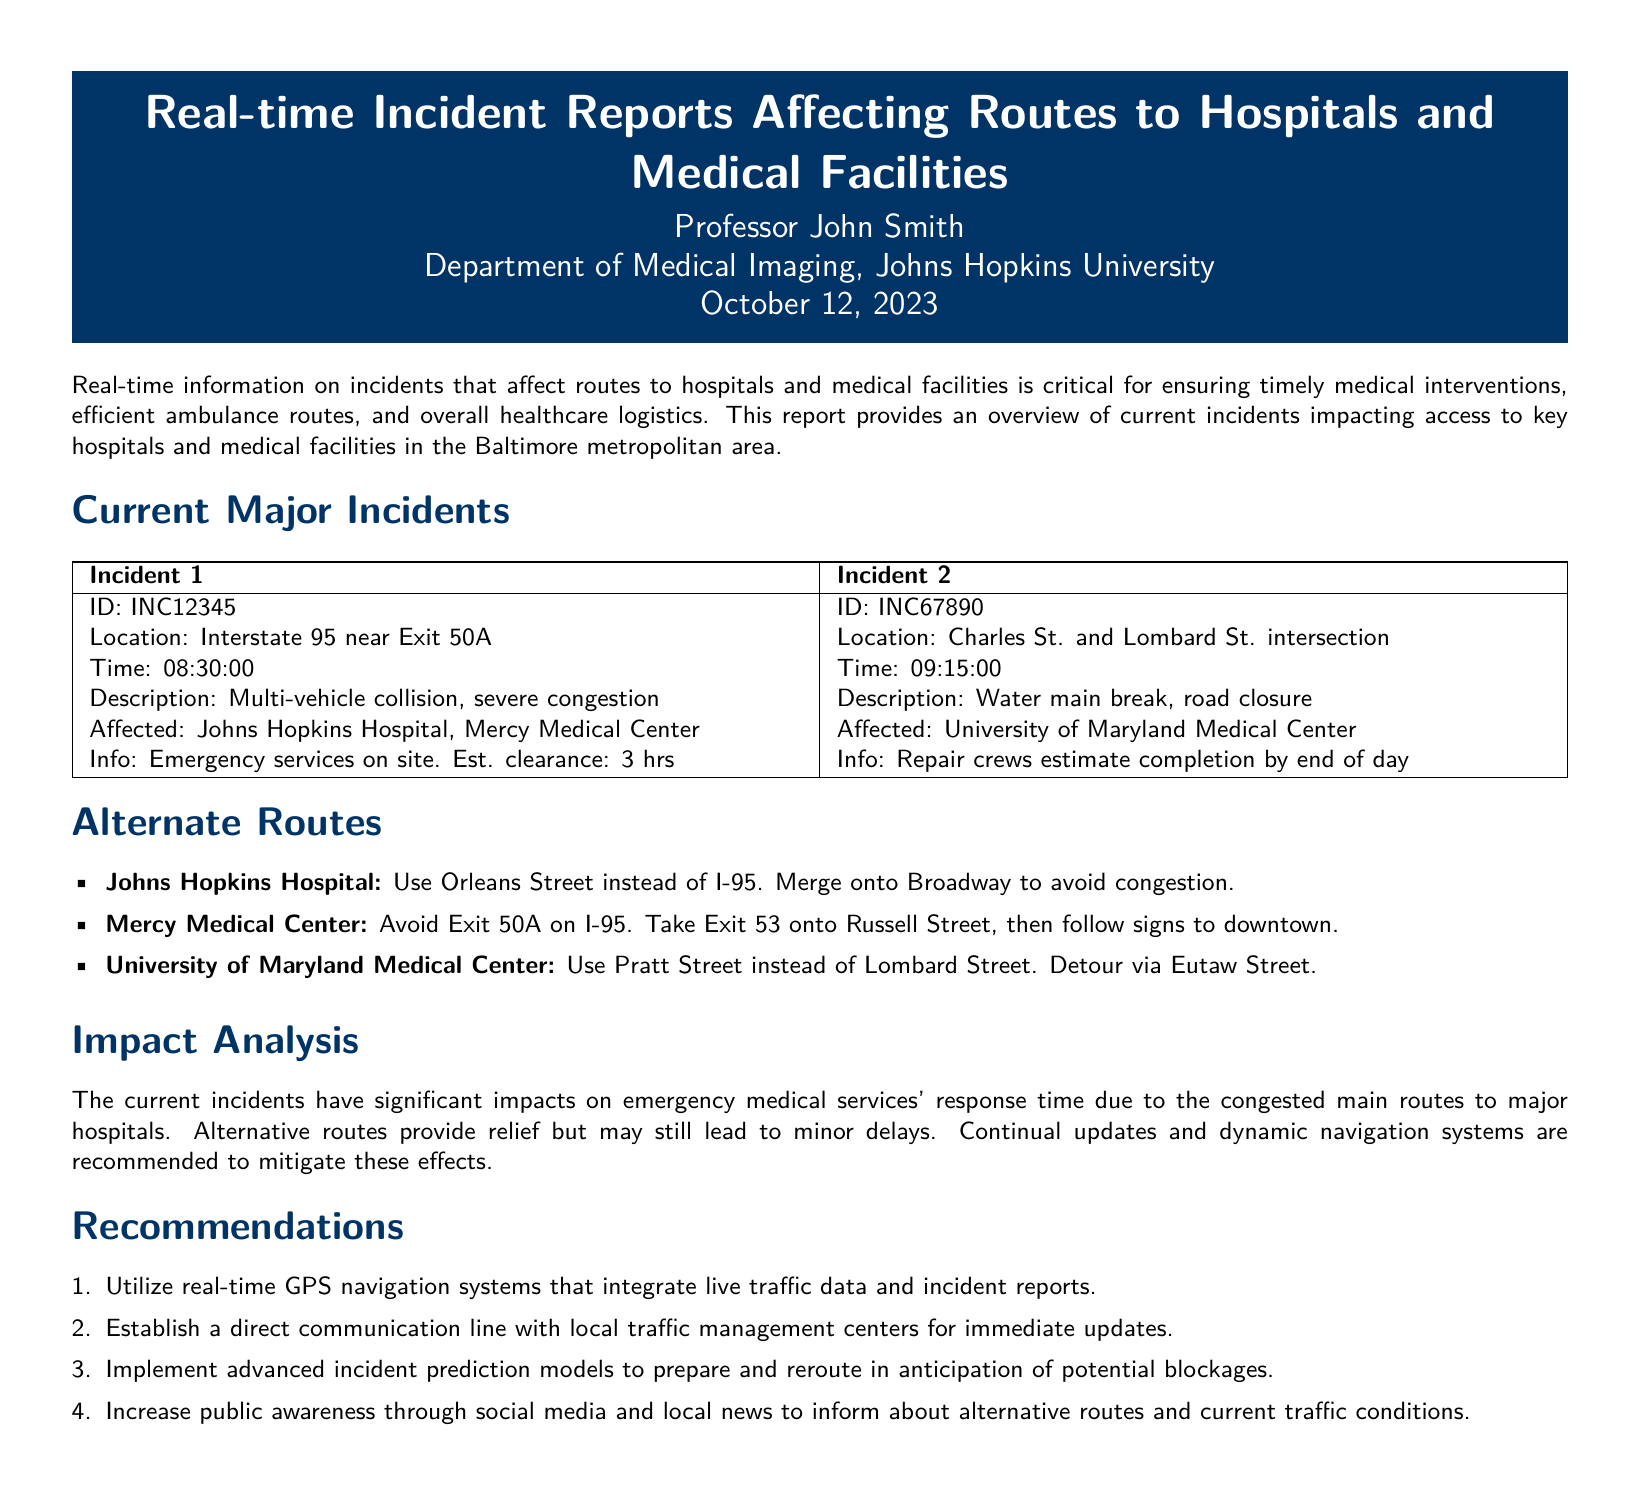What is the time of Incident 1? The time of Incident 1 is specified in the report as 08:30:00.
Answer: 08:30:00 What is the location of Incident 2? The report states that Incident 2 is located at the Charles St. and Lombard St. intersection.
Answer: Charles St. and Lombard St. intersection How many hospitals are affected by Incident 1? The document lists two hospitals affected by Incident 1: Johns Hopkins Hospital and Mercy Medical Center.
Answer: 2 What is the estimated clearance time for Incident 1? According to the report, the estimated clearance time for Incident 1 is 3 hours.
Answer: 3 hrs What alternative route is suggested for Johns Hopkins Hospital? The report suggests using Orleans Street instead of I-95 as an alternative route for Johns Hopkins Hospital.
Answer: Orleans Street What is the reason for the road closure at Incident 2? The document states that the road closure at Incident 2 is due to a water main break.
Answer: Water main break What is recommended for increasing public awareness? The report recommends increasing public awareness through social media and local news.
Answer: Social media and local news What is the main focus of this document? The main focus of the document is providing real-time information on incidents affecting access to hospitals and medical facilities.
Answer: Real-time information on incidents 